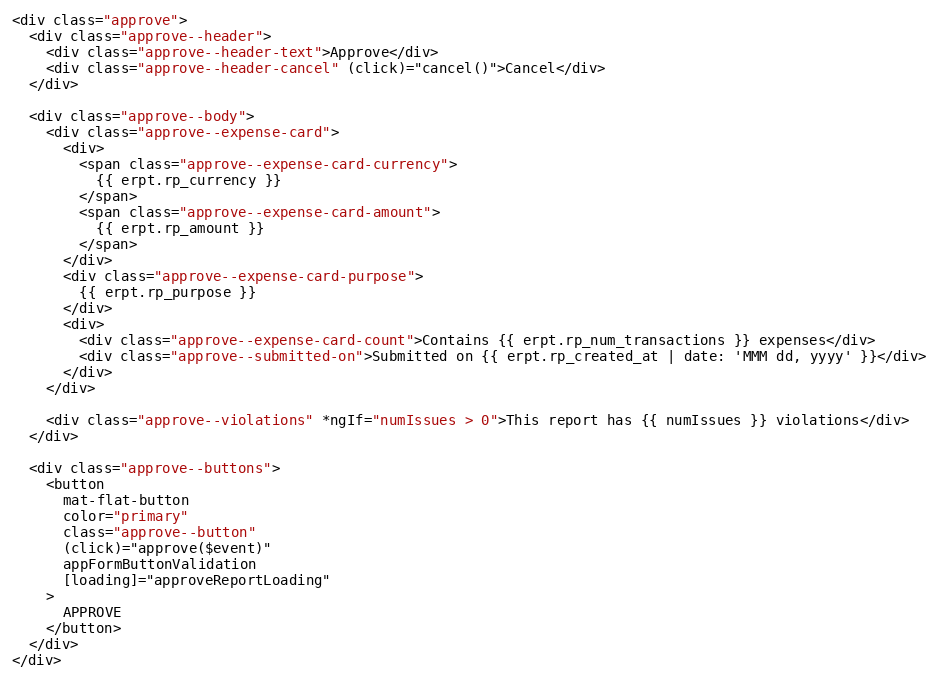Convert code to text. <code><loc_0><loc_0><loc_500><loc_500><_HTML_><div class="approve">
  <div class="approve--header">
    <div class="approve--header-text">Approve</div>
    <div class="approve--header-cancel" (click)="cancel()">Cancel</div>
  </div>

  <div class="approve--body">
    <div class="approve--expense-card">
      <div>
        <span class="approve--expense-card-currency">
          {{ erpt.rp_currency }}
        </span>
        <span class="approve--expense-card-amount">
          {{ erpt.rp_amount }}
        </span>
      </div>
      <div class="approve--expense-card-purpose">
        {{ erpt.rp_purpose }}
      </div>
      <div>
        <div class="approve--expense-card-count">Contains {{ erpt.rp_num_transactions }} expenses</div>
        <div class="approve--submitted-on">Submitted on {{ erpt.rp_created_at | date: 'MMM dd, yyyy' }}</div>
      </div>
    </div>

    <div class="approve--violations" *ngIf="numIssues > 0">This report has {{ numIssues }} violations</div>
  </div>

  <div class="approve--buttons">
    <button
      mat-flat-button
      color="primary"
      class="approve--button"
      (click)="approve($event)"
      appFormButtonValidation
      [loading]="approveReportLoading"
    >
      APPROVE
    </button>
  </div>
</div>
</code> 